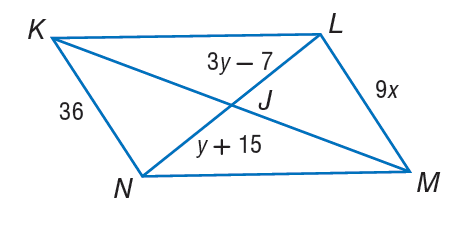Answer the mathemtical geometry problem and directly provide the correct option letter.
Question: If K L M N is a parallelogram, find y.
Choices: A: 11 B: 17 C: 26 D: 28 A 